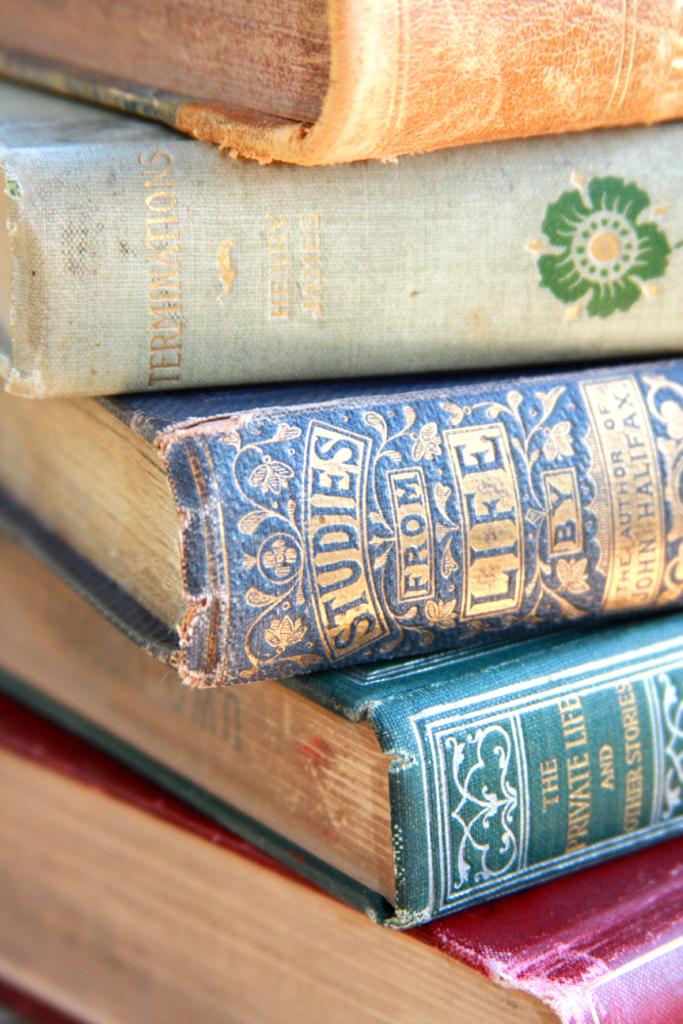What is the title of the periwinkle book?
Keep it short and to the point. Studies from life. Who is the author of the blue book?
Provide a short and direct response. John halifax. 